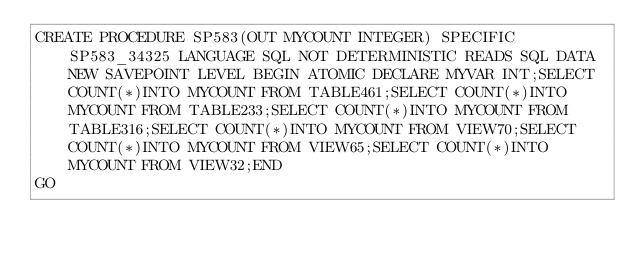<code> <loc_0><loc_0><loc_500><loc_500><_SQL_>CREATE PROCEDURE SP583(OUT MYCOUNT INTEGER) SPECIFIC SP583_34325 LANGUAGE SQL NOT DETERMINISTIC READS SQL DATA NEW SAVEPOINT LEVEL BEGIN ATOMIC DECLARE MYVAR INT;SELECT COUNT(*)INTO MYCOUNT FROM TABLE461;SELECT COUNT(*)INTO MYCOUNT FROM TABLE233;SELECT COUNT(*)INTO MYCOUNT FROM TABLE316;SELECT COUNT(*)INTO MYCOUNT FROM VIEW70;SELECT COUNT(*)INTO MYCOUNT FROM VIEW65;SELECT COUNT(*)INTO MYCOUNT FROM VIEW32;END
GO</code> 